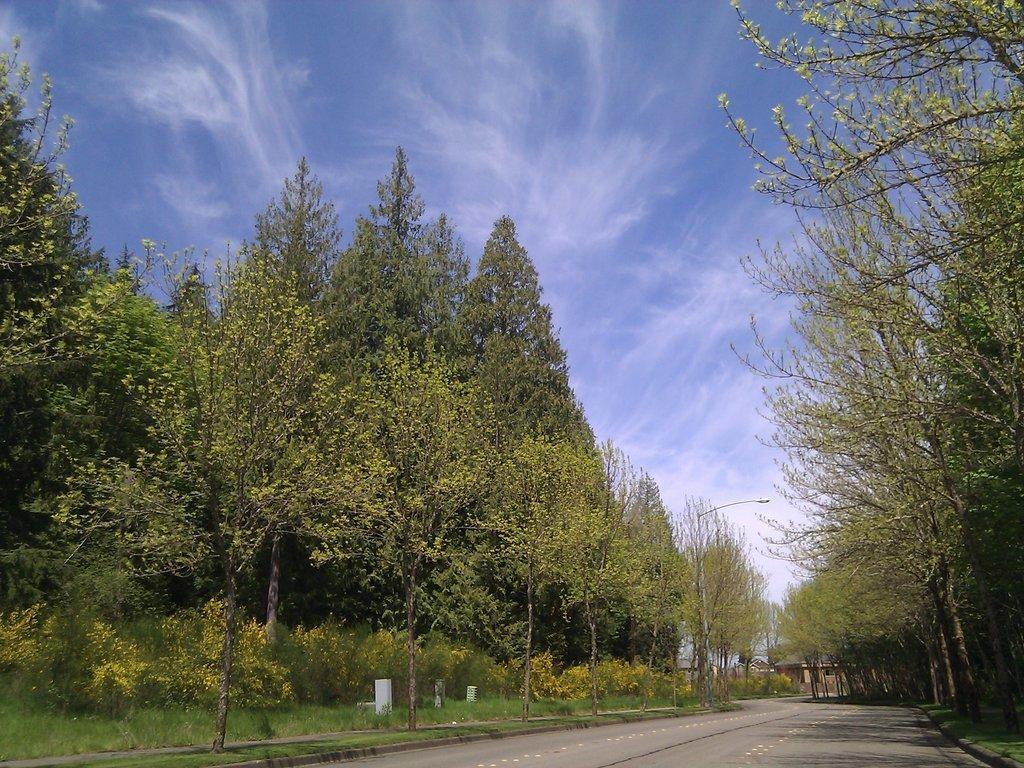How would you summarize this image in a sentence or two? In this image, we can see trees and at the bottom, there is road. 